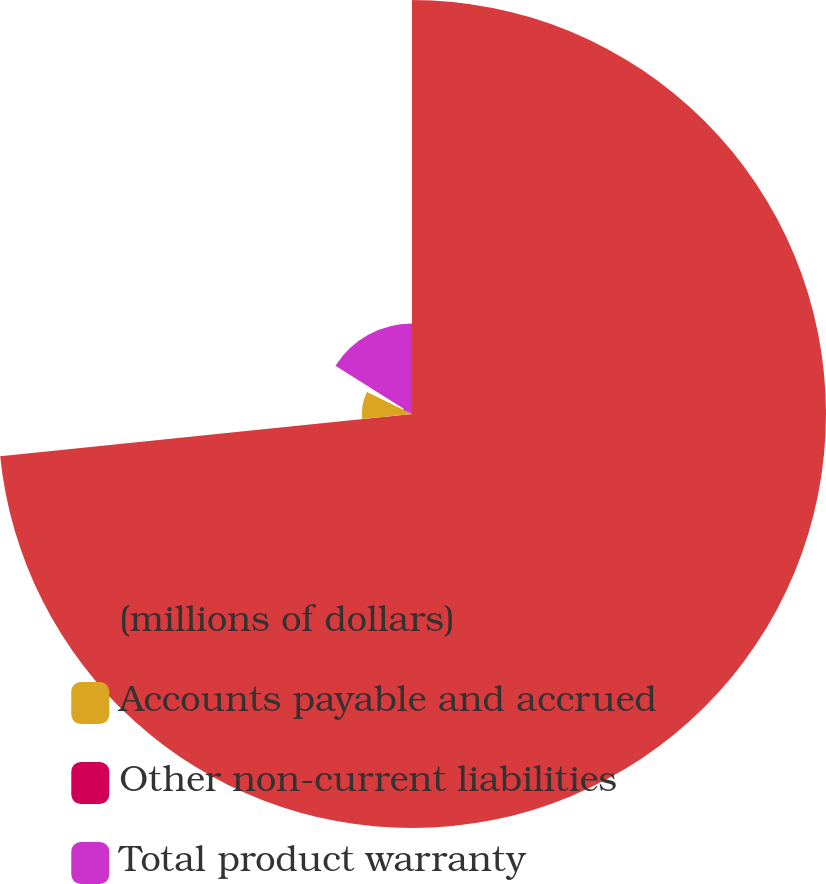<chart> <loc_0><loc_0><loc_500><loc_500><pie_chart><fcel>(millions of dollars)<fcel>Accounts payable and accrued<fcel>Other non-current liabilities<fcel>Total product warranty<nl><fcel>73.37%<fcel>8.88%<fcel>1.71%<fcel>16.04%<nl></chart> 